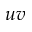<formula> <loc_0><loc_0><loc_500><loc_500>u v</formula> 